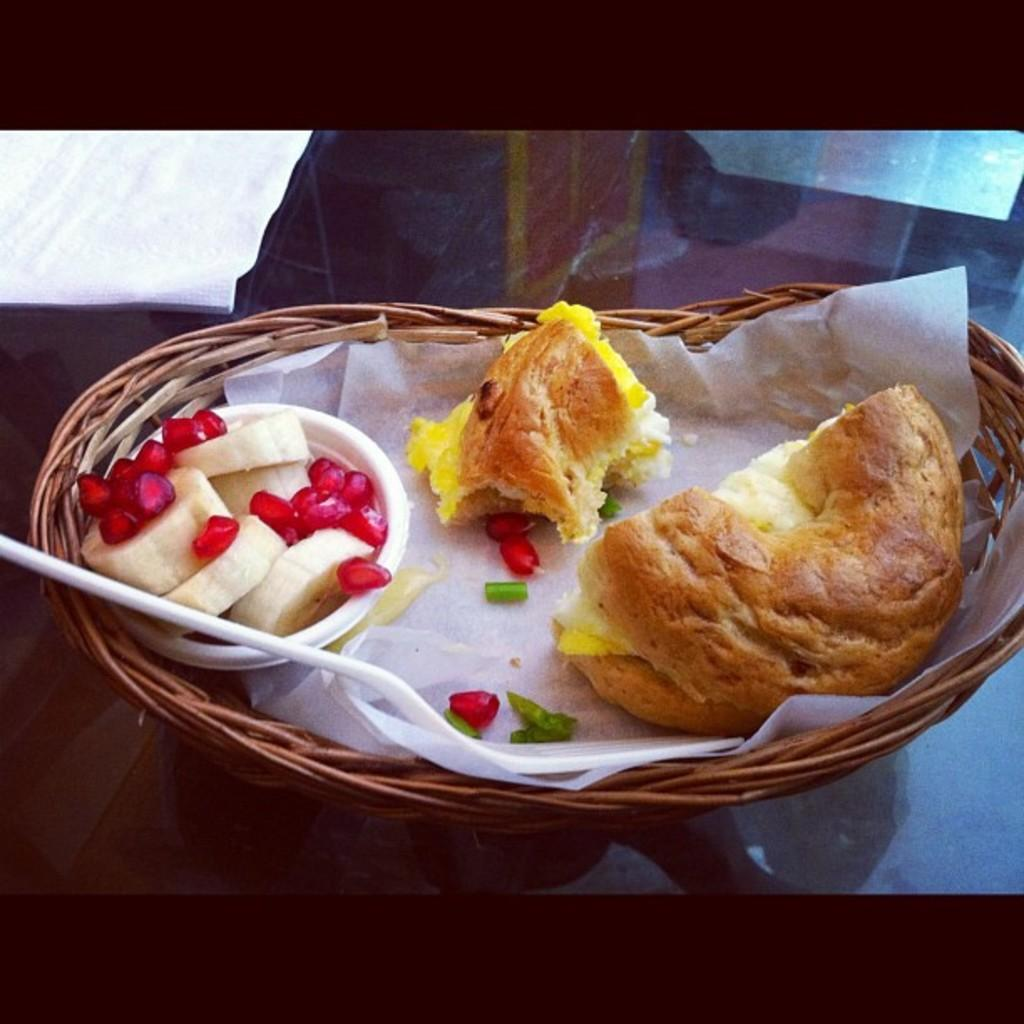What type of fruit seeds are visible in the image? There are pomegranate seeds in the image. What other fruit is present in the image? There are banana slices in the image. Where are the pomegranate seeds and banana slices located? They are in a cup in the image. What utensil can be seen in the image? There is a spoon in the image. What type of food is in a basket in the image? There is bread in a basket in the image. On what surface is the basket placed? The basket is placed on a surface in the image. What type of cave is visible in the image? There is no cave present in the image. What type of writing can be seen on the bread in the basket? There is no writing visible on the bread in the image. 